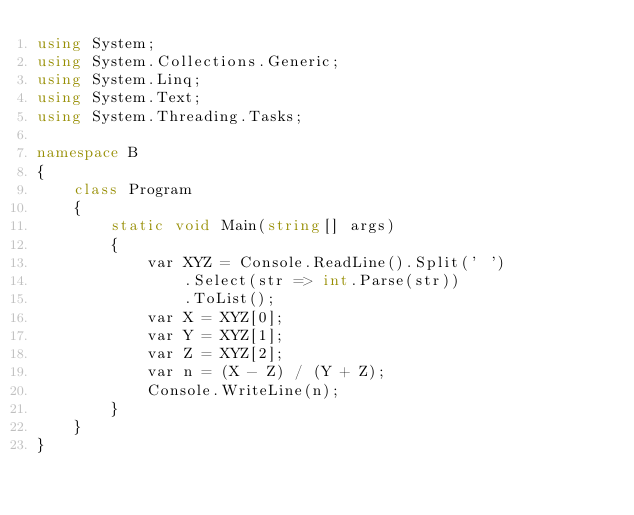<code> <loc_0><loc_0><loc_500><loc_500><_C#_>using System;
using System.Collections.Generic;
using System.Linq;
using System.Text;
using System.Threading.Tasks;

namespace B
{
    class Program
    {
        static void Main(string[] args)
        {
            var XYZ = Console.ReadLine().Split(' ')
                .Select(str => int.Parse(str))
                .ToList();
            var X = XYZ[0];
            var Y = XYZ[1];
            var Z = XYZ[2];
            var n = (X - Z) / (Y + Z);
            Console.WriteLine(n);
        }
    }
}</code> 